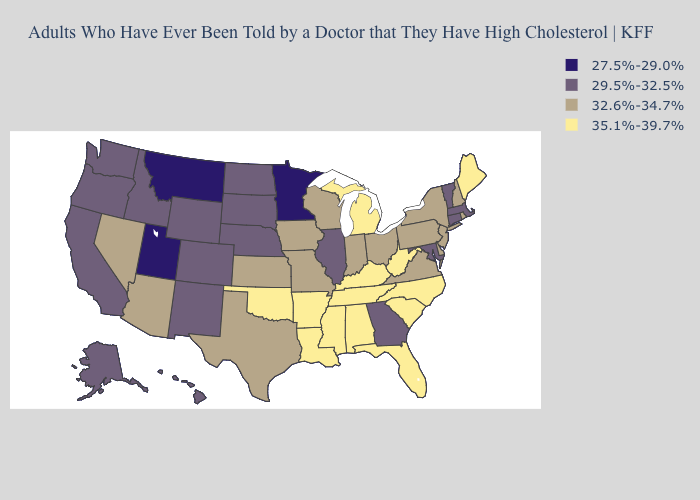Name the states that have a value in the range 32.6%-34.7%?
Short answer required. Arizona, Delaware, Indiana, Iowa, Kansas, Missouri, Nevada, New Hampshire, New Jersey, New York, Ohio, Pennsylvania, Rhode Island, Texas, Virginia, Wisconsin. Does Minnesota have the lowest value in the USA?
Be succinct. Yes. Name the states that have a value in the range 29.5%-32.5%?
Short answer required. Alaska, California, Colorado, Connecticut, Georgia, Hawaii, Idaho, Illinois, Maryland, Massachusetts, Nebraska, New Mexico, North Dakota, Oregon, South Dakota, Vermont, Washington, Wyoming. What is the lowest value in the USA?
Answer briefly. 27.5%-29.0%. What is the value of Minnesota?
Be succinct. 27.5%-29.0%. What is the highest value in the West ?
Be succinct. 32.6%-34.7%. Does Arizona have a lower value than Texas?
Keep it brief. No. What is the lowest value in the USA?
Short answer required. 27.5%-29.0%. What is the value of North Dakota?
Concise answer only. 29.5%-32.5%. Does Arizona have a lower value than Tennessee?
Quick response, please. Yes. What is the lowest value in the Northeast?
Give a very brief answer. 29.5%-32.5%. What is the lowest value in the USA?
Give a very brief answer. 27.5%-29.0%. What is the value of Alaska?
Short answer required. 29.5%-32.5%. Name the states that have a value in the range 27.5%-29.0%?
Write a very short answer. Minnesota, Montana, Utah. Which states have the highest value in the USA?
Be succinct. Alabama, Arkansas, Florida, Kentucky, Louisiana, Maine, Michigan, Mississippi, North Carolina, Oklahoma, South Carolina, Tennessee, West Virginia. 